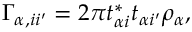<formula> <loc_0><loc_0><loc_500><loc_500>\Gamma _ { \alpha , i i ^ { \prime } } = 2 \pi t _ { \alpha i } ^ { * } t _ { \alpha i ^ { \prime } } \rho _ { \alpha } ,</formula> 